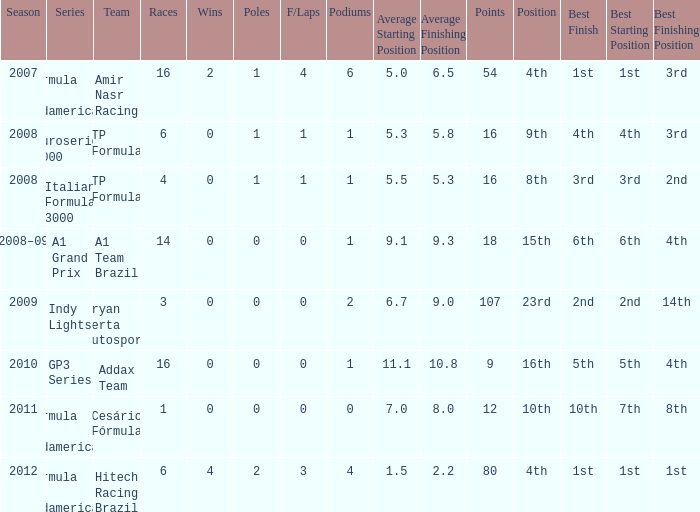What team did he compete for in the GP3 series? Addax Team. 